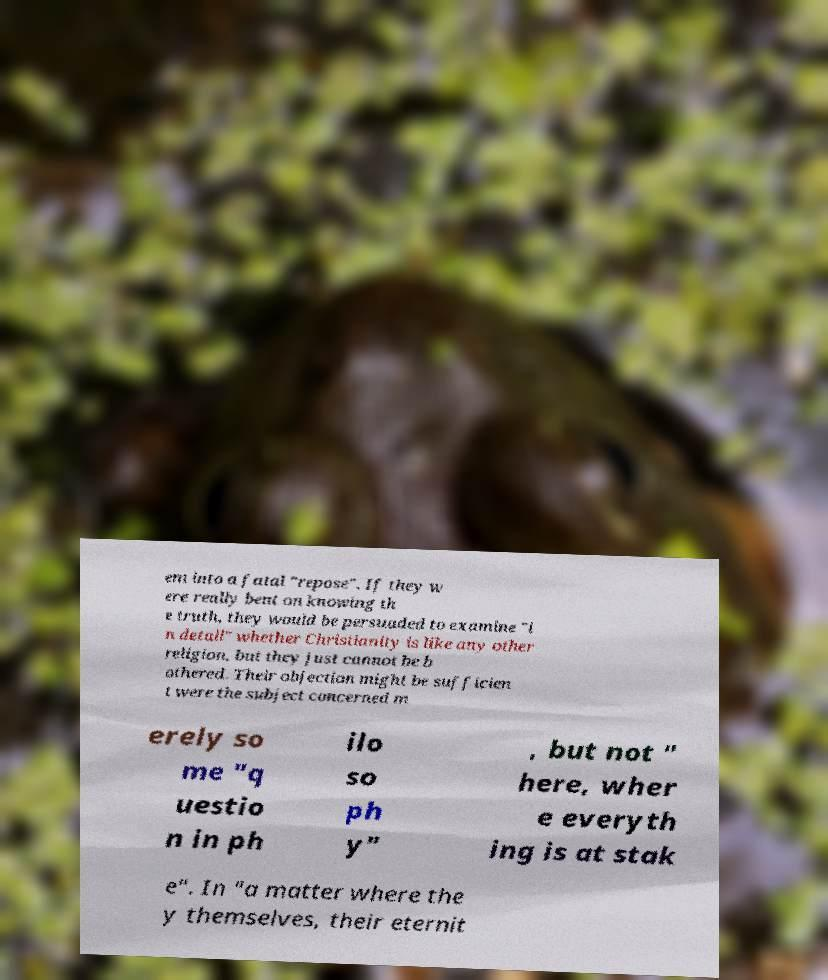Could you assist in decoding the text presented in this image and type it out clearly? em into a fatal "repose". If they w ere really bent on knowing th e truth, they would be persuaded to examine "i n detail" whether Christianity is like any other religion, but they just cannot be b othered. Their objection might be sufficien t were the subject concerned m erely so me "q uestio n in ph ilo so ph y" , but not " here, wher e everyth ing is at stak e". In "a matter where the y themselves, their eternit 